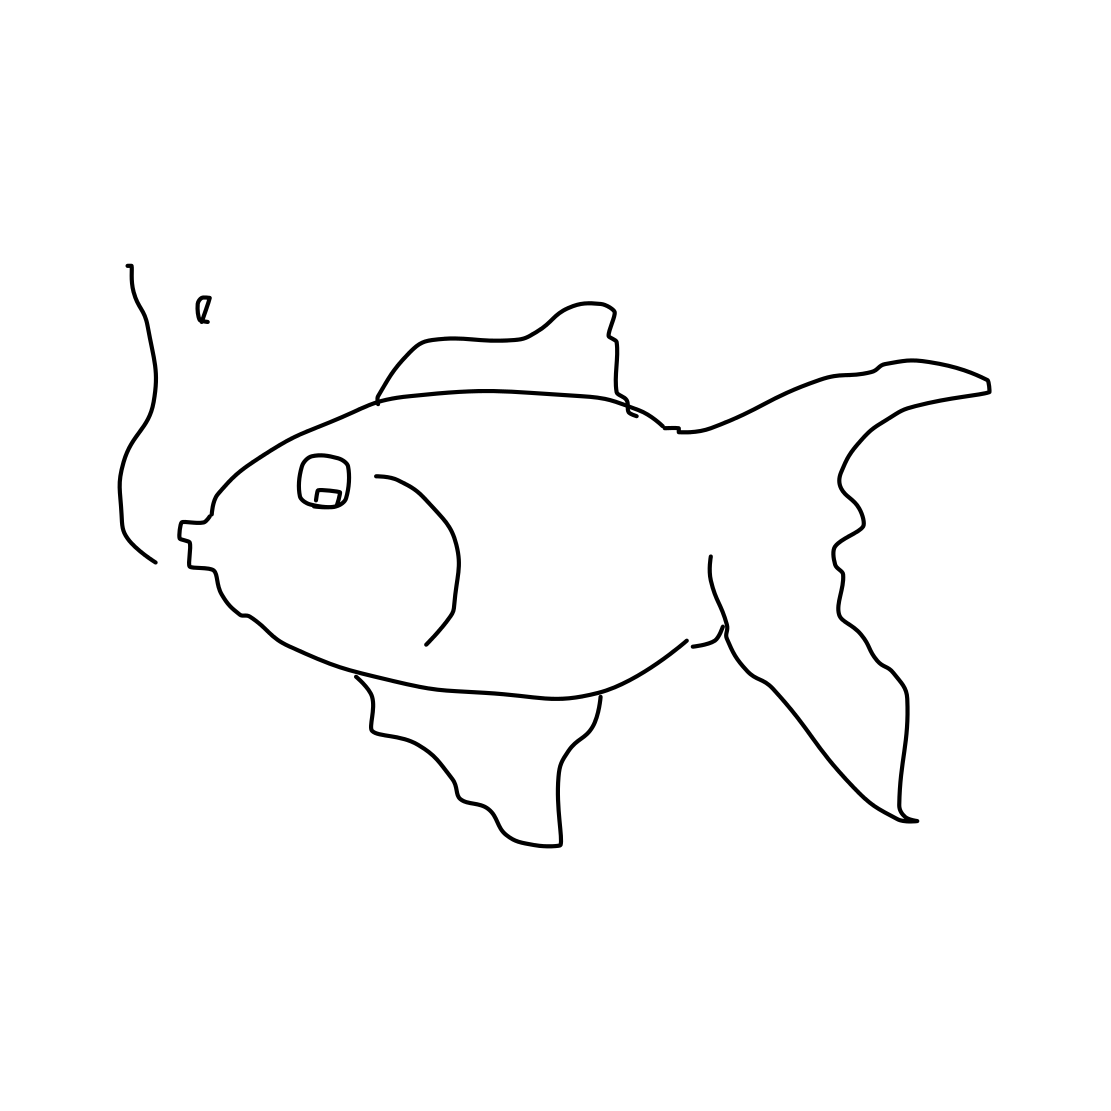What emotions does this image evoke? The simplistic nature of the drawing may evoke a sense of whimsy and light-heartedness. Its uncomplicated lines and unrefined finish can impart a casual, carefree vibe that encourages viewers to fill in the gaps with their own imagination. Could this image serve an educational purpose? Certainly! This image could be used in an educational setting to illustrate the versatility of line art, or to demonstrate the foundational shapes and forms that can represent more complex subjects. It might also be a starting point for a lesson on sketching techniques or an exercise in visual perception, where students interpret the drawing in their own way. 